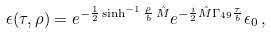<formula> <loc_0><loc_0><loc_500><loc_500>\epsilon ( \tau , \rho ) = e ^ { - \frac { 1 } { 2 } \sinh ^ { - 1 } \frac { \rho } { b } \, \hat { M } } e ^ { - \frac { i } { 2 } \hat { M } \Gamma _ { 4 9 } \frac { \tau } { b } } \epsilon _ { 0 } \, ,</formula> 